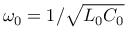<formula> <loc_0><loc_0><loc_500><loc_500>\omega _ { 0 } = 1 / \sqrt { L _ { 0 } C _ { 0 } }</formula> 